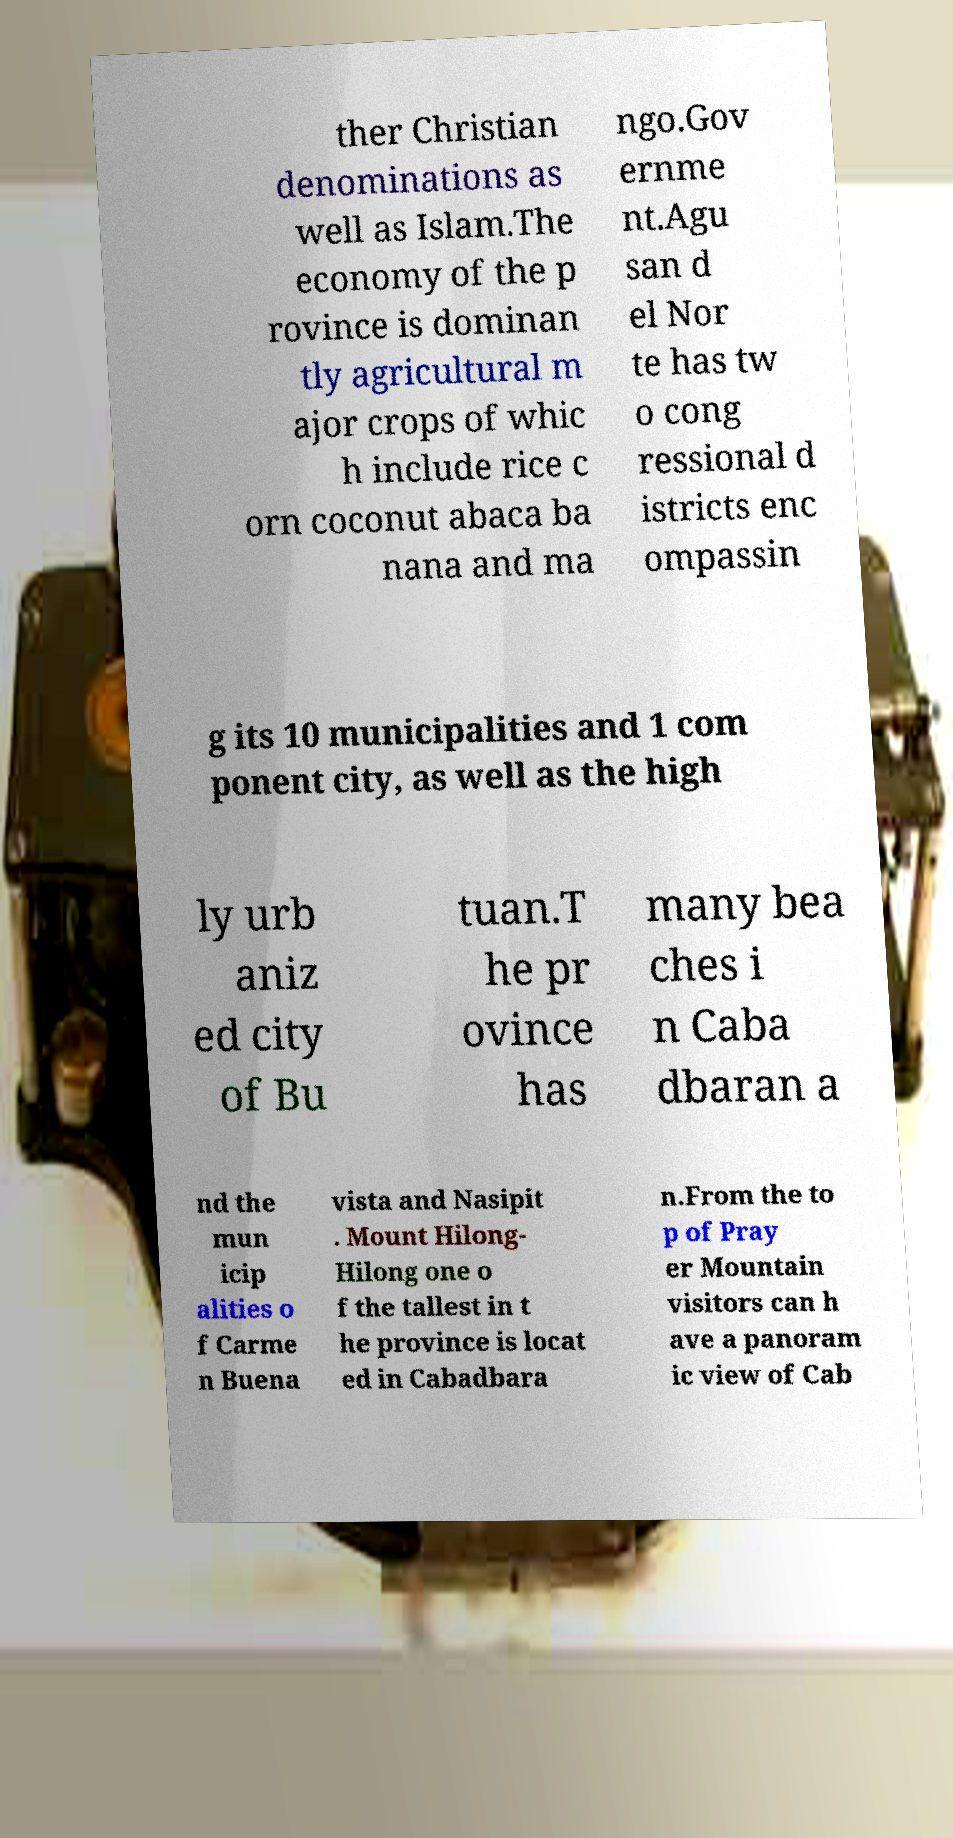For documentation purposes, I need the text within this image transcribed. Could you provide that? ther Christian denominations as well as Islam.The economy of the p rovince is dominan tly agricultural m ajor crops of whic h include rice c orn coconut abaca ba nana and ma ngo.Gov ernme nt.Agu san d el Nor te has tw o cong ressional d istricts enc ompassin g its 10 municipalities and 1 com ponent city, as well as the high ly urb aniz ed city of Bu tuan.T he pr ovince has many bea ches i n Caba dbaran a nd the mun icip alities o f Carme n Buena vista and Nasipit . Mount Hilong- Hilong one o f the tallest in t he province is locat ed in Cabadbara n.From the to p of Pray er Mountain visitors can h ave a panoram ic view of Cab 